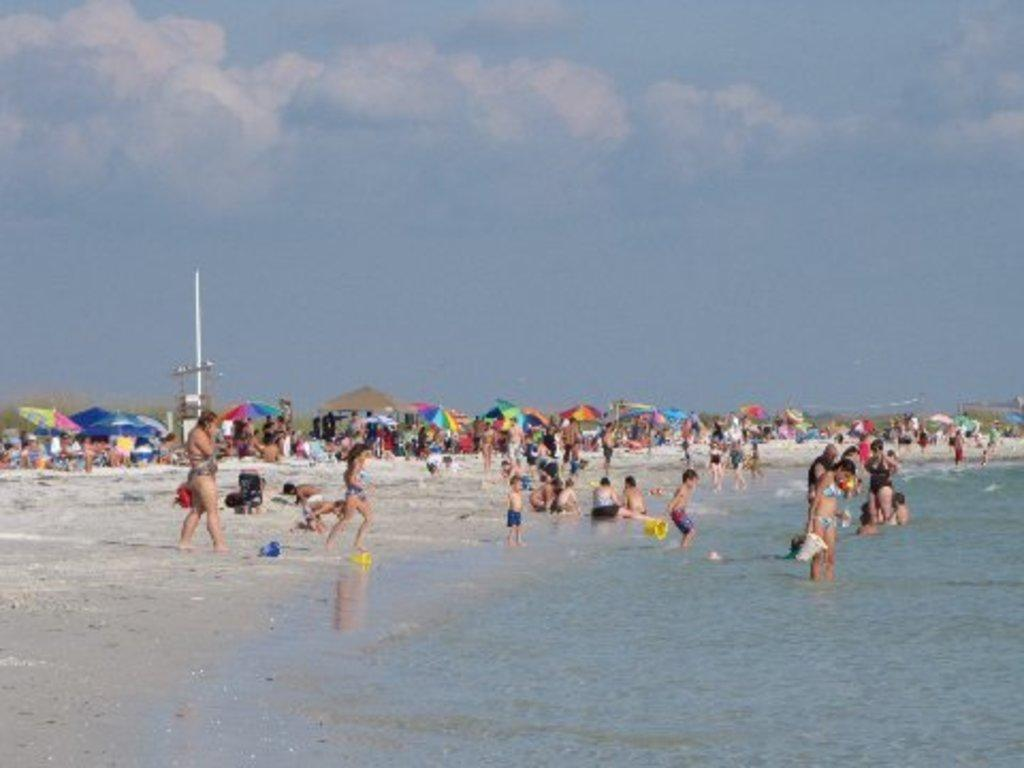How many people are in the image? There are people in the image, but the exact number is not specified. What are some people doing in the image? Some people are standing in water, while others are standing on the ground. What objects can be seen in the image that might provide shade or protection from the elements? There are umbrellas in the image. What can be seen in the background of the image? There are clouds and the sky visible in the background. What type of sweater is being worn by the person experiencing the thrill of addition in the image? There is no person experiencing the thrill of addition or wearing a sweater in the image. 